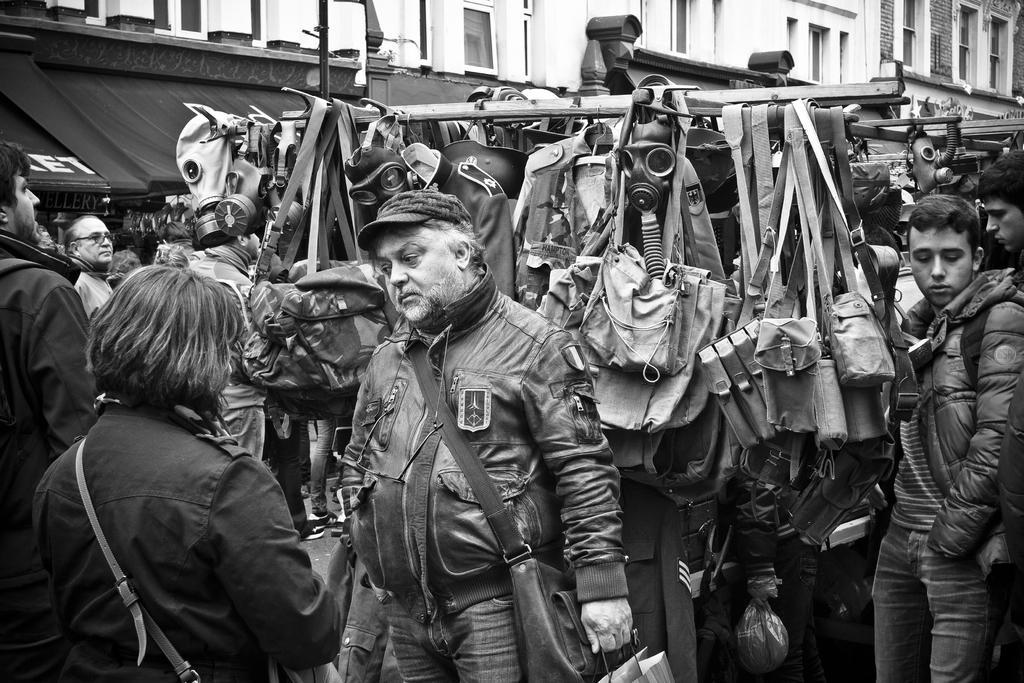Could you give a brief overview of what you see in this image? In the middle a man is standing, he wore coat, trouser,and also a cap. On the left side a woman is there. In the middle there are bags. 